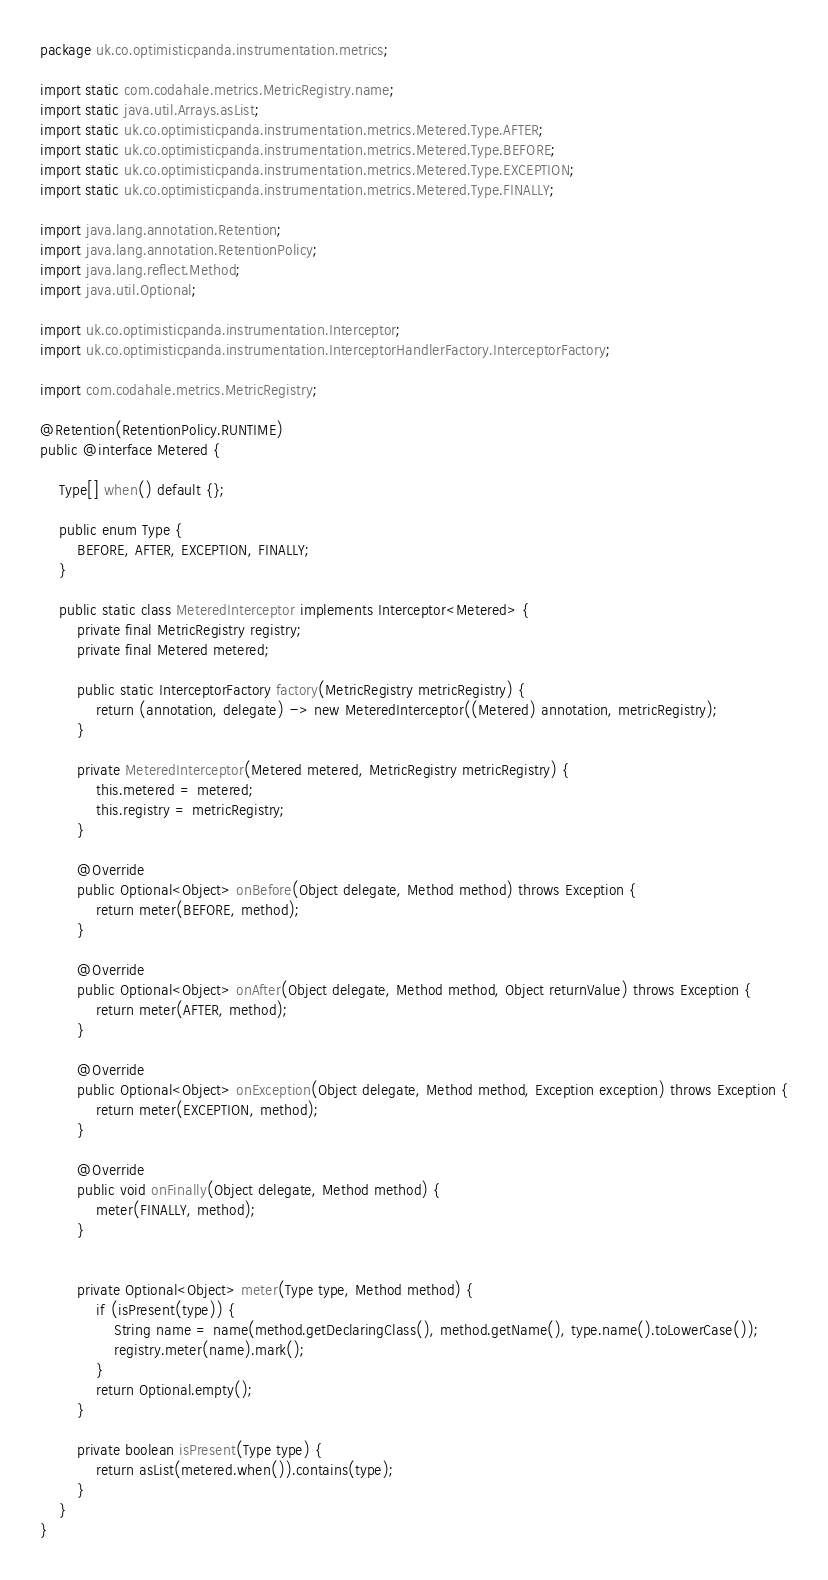<code> <loc_0><loc_0><loc_500><loc_500><_Java_>package uk.co.optimisticpanda.instrumentation.metrics;

import static com.codahale.metrics.MetricRegistry.name;
import static java.util.Arrays.asList;
import static uk.co.optimisticpanda.instrumentation.metrics.Metered.Type.AFTER;
import static uk.co.optimisticpanda.instrumentation.metrics.Metered.Type.BEFORE;
import static uk.co.optimisticpanda.instrumentation.metrics.Metered.Type.EXCEPTION;
import static uk.co.optimisticpanda.instrumentation.metrics.Metered.Type.FINALLY;

import java.lang.annotation.Retention;
import java.lang.annotation.RetentionPolicy;
import java.lang.reflect.Method;
import java.util.Optional;

import uk.co.optimisticpanda.instrumentation.Interceptor;
import uk.co.optimisticpanda.instrumentation.InterceptorHandlerFactory.InterceptorFactory;

import com.codahale.metrics.MetricRegistry;

@Retention(RetentionPolicy.RUNTIME)
public @interface Metered {
    
    Type[] when() default {};
    
    public enum Type {
        BEFORE, AFTER, EXCEPTION, FINALLY;
    }
    
    public static class MeteredInterceptor implements Interceptor<Metered> {
        private final MetricRegistry registry;
        private final Metered metered;

        public static InterceptorFactory factory(MetricRegistry metricRegistry) {
            return (annotation, delegate) -> new MeteredInterceptor((Metered) annotation, metricRegistry);
        }
        
        private MeteredInterceptor(Metered metered, MetricRegistry metricRegistry) {
            this.metered = metered;
            this.registry = metricRegistry;
        }

        @Override
        public Optional<Object> onBefore(Object delegate, Method method) throws Exception {
            return meter(BEFORE, method);
        }
        
        @Override
        public Optional<Object> onAfter(Object delegate, Method method, Object returnValue) throws Exception {
            return meter(AFTER, method);
        }
        
        @Override
        public Optional<Object> onException(Object delegate, Method method, Exception exception) throws Exception {
            return meter(EXCEPTION, method);
        }

        @Override
        public void onFinally(Object delegate, Method method) {
            meter(FINALLY, method);
        }

        
        private Optional<Object> meter(Type type, Method method) {
            if (isPresent(type)) {
                String name = name(method.getDeclaringClass(), method.getName(), type.name().toLowerCase());
                registry.meter(name).mark();
            }
            return Optional.empty();
        }
        
        private boolean isPresent(Type type) {
            return asList(metered.when()).contains(type);
        }
    }
}</code> 